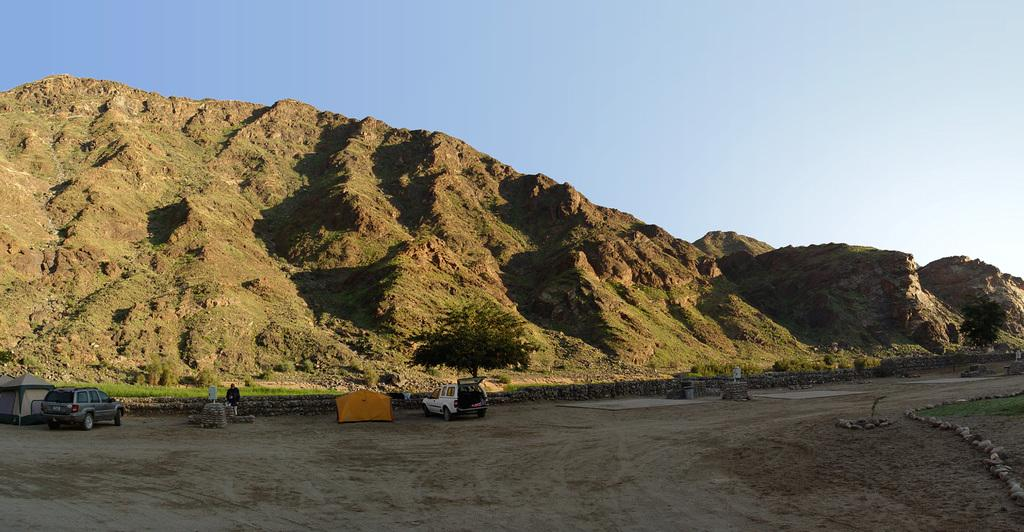How many cars are in the image? There are two cars in the image. What else can be seen in the image besides the cars? There is a man and a tent to the left of the image. What is visible at the bottom of the image? The ground is visible at the bottom of the image. What type of natural feature is visible in the background of the image? There are mountains in the background of the image. What is visible at the top of the image? The sky is visible at the top of the image. Where is the grandfather sitting in the image? There is no grandfather present in the image. What type of worm can be seen crawling on the tent in the image? There are no worms present in the image. 